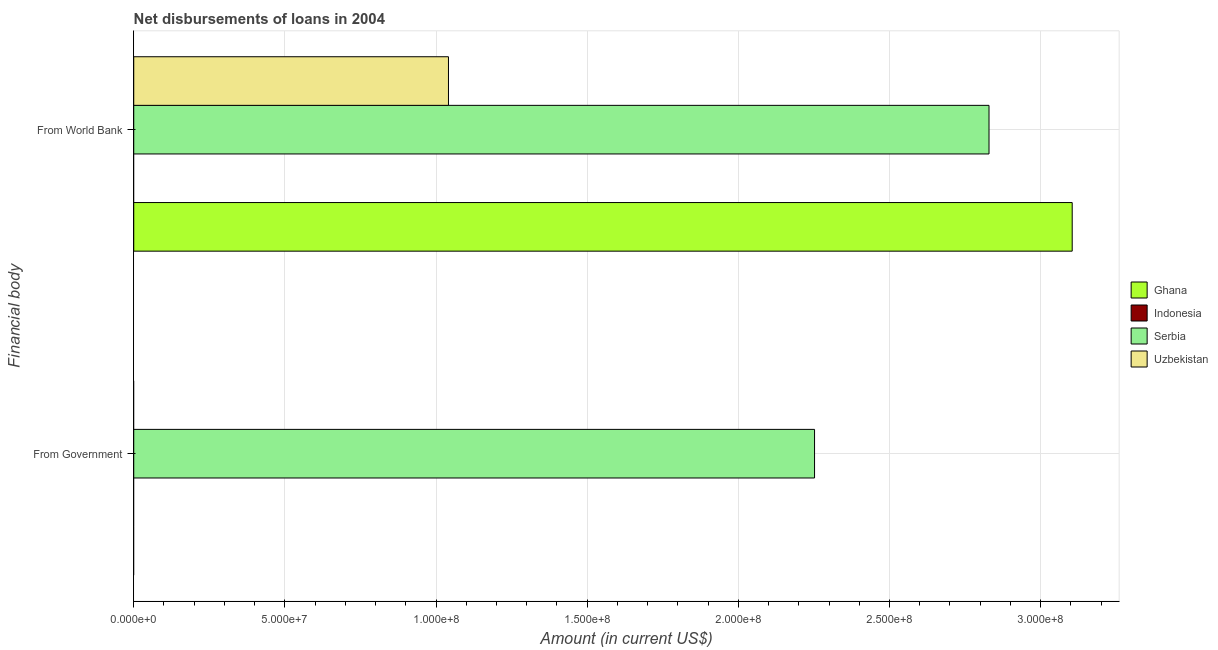How many different coloured bars are there?
Your answer should be very brief. 3. Are the number of bars per tick equal to the number of legend labels?
Provide a succinct answer. No. Are the number of bars on each tick of the Y-axis equal?
Offer a very short reply. No. How many bars are there on the 2nd tick from the top?
Keep it short and to the point. 1. How many bars are there on the 2nd tick from the bottom?
Make the answer very short. 3. What is the label of the 1st group of bars from the top?
Ensure brevity in your answer.  From World Bank. What is the net disbursements of loan from government in Ghana?
Your answer should be compact. 0. Across all countries, what is the maximum net disbursements of loan from government?
Your response must be concise. 2.25e+08. Across all countries, what is the minimum net disbursements of loan from world bank?
Offer a terse response. 0. In which country was the net disbursements of loan from world bank maximum?
Provide a succinct answer. Ghana. What is the total net disbursements of loan from government in the graph?
Keep it short and to the point. 2.25e+08. What is the difference between the net disbursements of loan from government in Uzbekistan and the net disbursements of loan from world bank in Serbia?
Ensure brevity in your answer.  -2.83e+08. What is the average net disbursements of loan from government per country?
Your answer should be very brief. 5.63e+07. What is the difference between the net disbursements of loan from world bank and net disbursements of loan from government in Serbia?
Your answer should be compact. 5.77e+07. What is the ratio of the net disbursements of loan from world bank in Ghana to that in Uzbekistan?
Provide a short and direct response. 2.98. How many bars are there?
Your response must be concise. 4. What is the difference between two consecutive major ticks on the X-axis?
Your answer should be compact. 5.00e+07. Are the values on the major ticks of X-axis written in scientific E-notation?
Make the answer very short. Yes. What is the title of the graph?
Ensure brevity in your answer.  Net disbursements of loans in 2004. Does "Russian Federation" appear as one of the legend labels in the graph?
Keep it short and to the point. No. What is the label or title of the X-axis?
Ensure brevity in your answer.  Amount (in current US$). What is the label or title of the Y-axis?
Make the answer very short. Financial body. What is the Amount (in current US$) of Indonesia in From Government?
Ensure brevity in your answer.  0. What is the Amount (in current US$) in Serbia in From Government?
Ensure brevity in your answer.  2.25e+08. What is the Amount (in current US$) in Uzbekistan in From Government?
Give a very brief answer. 0. What is the Amount (in current US$) of Ghana in From World Bank?
Provide a succinct answer. 3.10e+08. What is the Amount (in current US$) in Indonesia in From World Bank?
Your answer should be very brief. 0. What is the Amount (in current US$) in Serbia in From World Bank?
Offer a terse response. 2.83e+08. What is the Amount (in current US$) of Uzbekistan in From World Bank?
Give a very brief answer. 1.04e+08. Across all Financial body, what is the maximum Amount (in current US$) of Ghana?
Make the answer very short. 3.10e+08. Across all Financial body, what is the maximum Amount (in current US$) of Serbia?
Give a very brief answer. 2.83e+08. Across all Financial body, what is the maximum Amount (in current US$) in Uzbekistan?
Your answer should be compact. 1.04e+08. Across all Financial body, what is the minimum Amount (in current US$) in Ghana?
Keep it short and to the point. 0. Across all Financial body, what is the minimum Amount (in current US$) in Serbia?
Provide a short and direct response. 2.25e+08. Across all Financial body, what is the minimum Amount (in current US$) of Uzbekistan?
Your answer should be very brief. 0. What is the total Amount (in current US$) of Ghana in the graph?
Ensure brevity in your answer.  3.10e+08. What is the total Amount (in current US$) of Indonesia in the graph?
Provide a succinct answer. 0. What is the total Amount (in current US$) in Serbia in the graph?
Ensure brevity in your answer.  5.08e+08. What is the total Amount (in current US$) in Uzbekistan in the graph?
Keep it short and to the point. 1.04e+08. What is the difference between the Amount (in current US$) in Serbia in From Government and that in From World Bank?
Keep it short and to the point. -5.77e+07. What is the difference between the Amount (in current US$) in Serbia in From Government and the Amount (in current US$) in Uzbekistan in From World Bank?
Provide a short and direct response. 1.21e+08. What is the average Amount (in current US$) in Ghana per Financial body?
Provide a succinct answer. 1.55e+08. What is the average Amount (in current US$) of Serbia per Financial body?
Offer a very short reply. 2.54e+08. What is the average Amount (in current US$) in Uzbekistan per Financial body?
Ensure brevity in your answer.  5.21e+07. What is the difference between the Amount (in current US$) of Ghana and Amount (in current US$) of Serbia in From World Bank?
Your response must be concise. 2.75e+07. What is the difference between the Amount (in current US$) of Ghana and Amount (in current US$) of Uzbekistan in From World Bank?
Give a very brief answer. 2.06e+08. What is the difference between the Amount (in current US$) in Serbia and Amount (in current US$) in Uzbekistan in From World Bank?
Keep it short and to the point. 1.79e+08. What is the ratio of the Amount (in current US$) of Serbia in From Government to that in From World Bank?
Provide a succinct answer. 0.8. What is the difference between the highest and the second highest Amount (in current US$) in Serbia?
Ensure brevity in your answer.  5.77e+07. What is the difference between the highest and the lowest Amount (in current US$) in Ghana?
Keep it short and to the point. 3.10e+08. What is the difference between the highest and the lowest Amount (in current US$) in Serbia?
Ensure brevity in your answer.  5.77e+07. What is the difference between the highest and the lowest Amount (in current US$) of Uzbekistan?
Keep it short and to the point. 1.04e+08. 